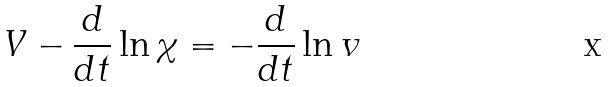Convert formula to latex. <formula><loc_0><loc_0><loc_500><loc_500>V - \frac { d } { d t } \ln \chi = - \frac { d } { d t } \ln v</formula> 